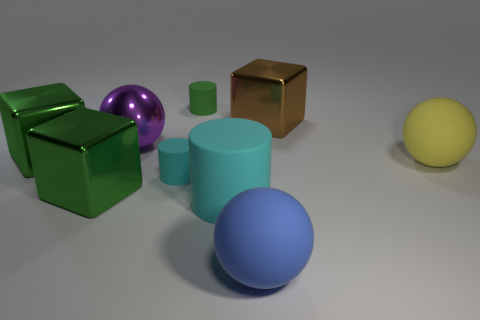Subtract all large rubber cylinders. How many cylinders are left? 2 Subtract all green cylinders. How many cylinders are left? 2 Subtract all spheres. How many objects are left? 6 Add 3 blue objects. How many blue objects are left? 4 Add 8 purple metallic objects. How many purple metallic objects exist? 9 Add 1 large cylinders. How many objects exist? 10 Subtract 0 yellow cubes. How many objects are left? 9 Subtract 2 cubes. How many cubes are left? 1 Subtract all cyan cylinders. Subtract all yellow balls. How many cylinders are left? 1 Subtract all red cubes. How many green cylinders are left? 1 